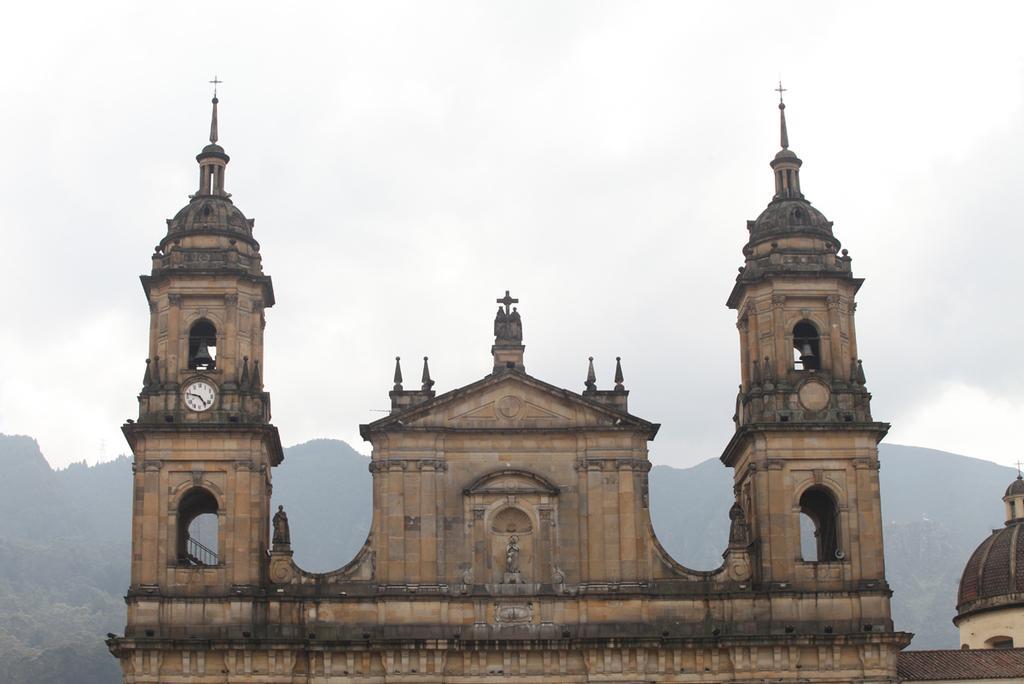Describe this image in one or two sentences. In this picture there is a monuments. Here we can see a wall clock. In the background we can see trees on the mountain. At the top we can see sky and clouds. 